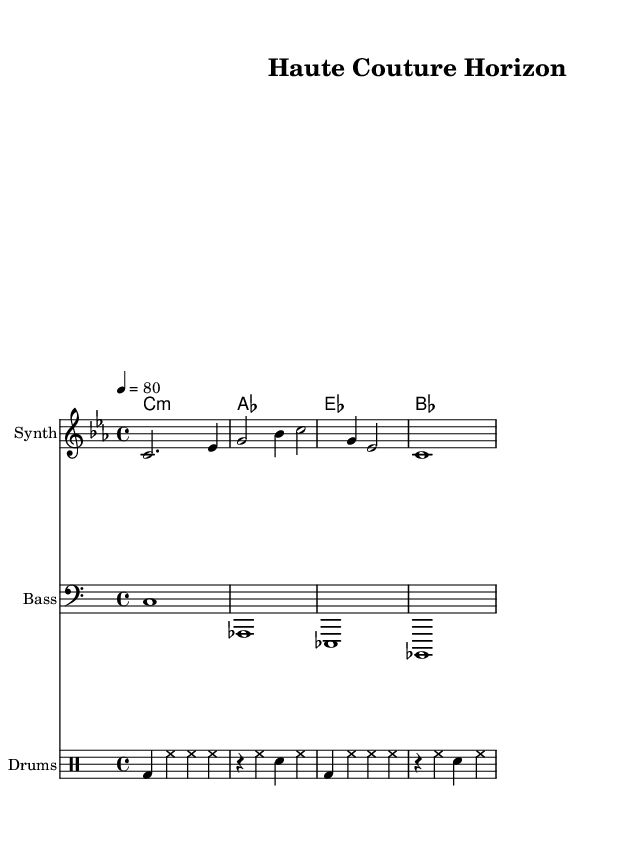What is the key signature of this music? The key signature is C minor, which contains three flats: B flat, E flat, and A flat, indicated at the beginning of the staff.
Answer: C minor What is the time signature of this piece? The time signature is 4/4, which is indicated right after the key signature. This means there are four beats per measure, and the quarter note gets one beat.
Answer: 4/4 What is the tempo marking for this score? The tempo marking is 80 beats per minute, indicated at the beginning of the score with the tempo text "4 = 80". This indicates a moderate tempo.
Answer: 80 What instrument is indicated for the main melody? The main melody is indicated to be played on a "Synth," which is specified in the staff header.
Answer: Synth How many measures does the main melody contain? The main melody consists of three measures, which can be counted by looking at the bar lines separating each measure within the melody.
Answer: 3 Which chord is played on the first beat of the second measure? The chord played on the first beat of the second measure is G, as indicated by the chord notation above the staff in the harmony section.
Answer: G What type of percussion is specified first in the percussion line? The first type of percussion specified in the percussion line is the bass drum, abbreviated as "bd", which is noted in the first measure.
Answer: Bass drum 